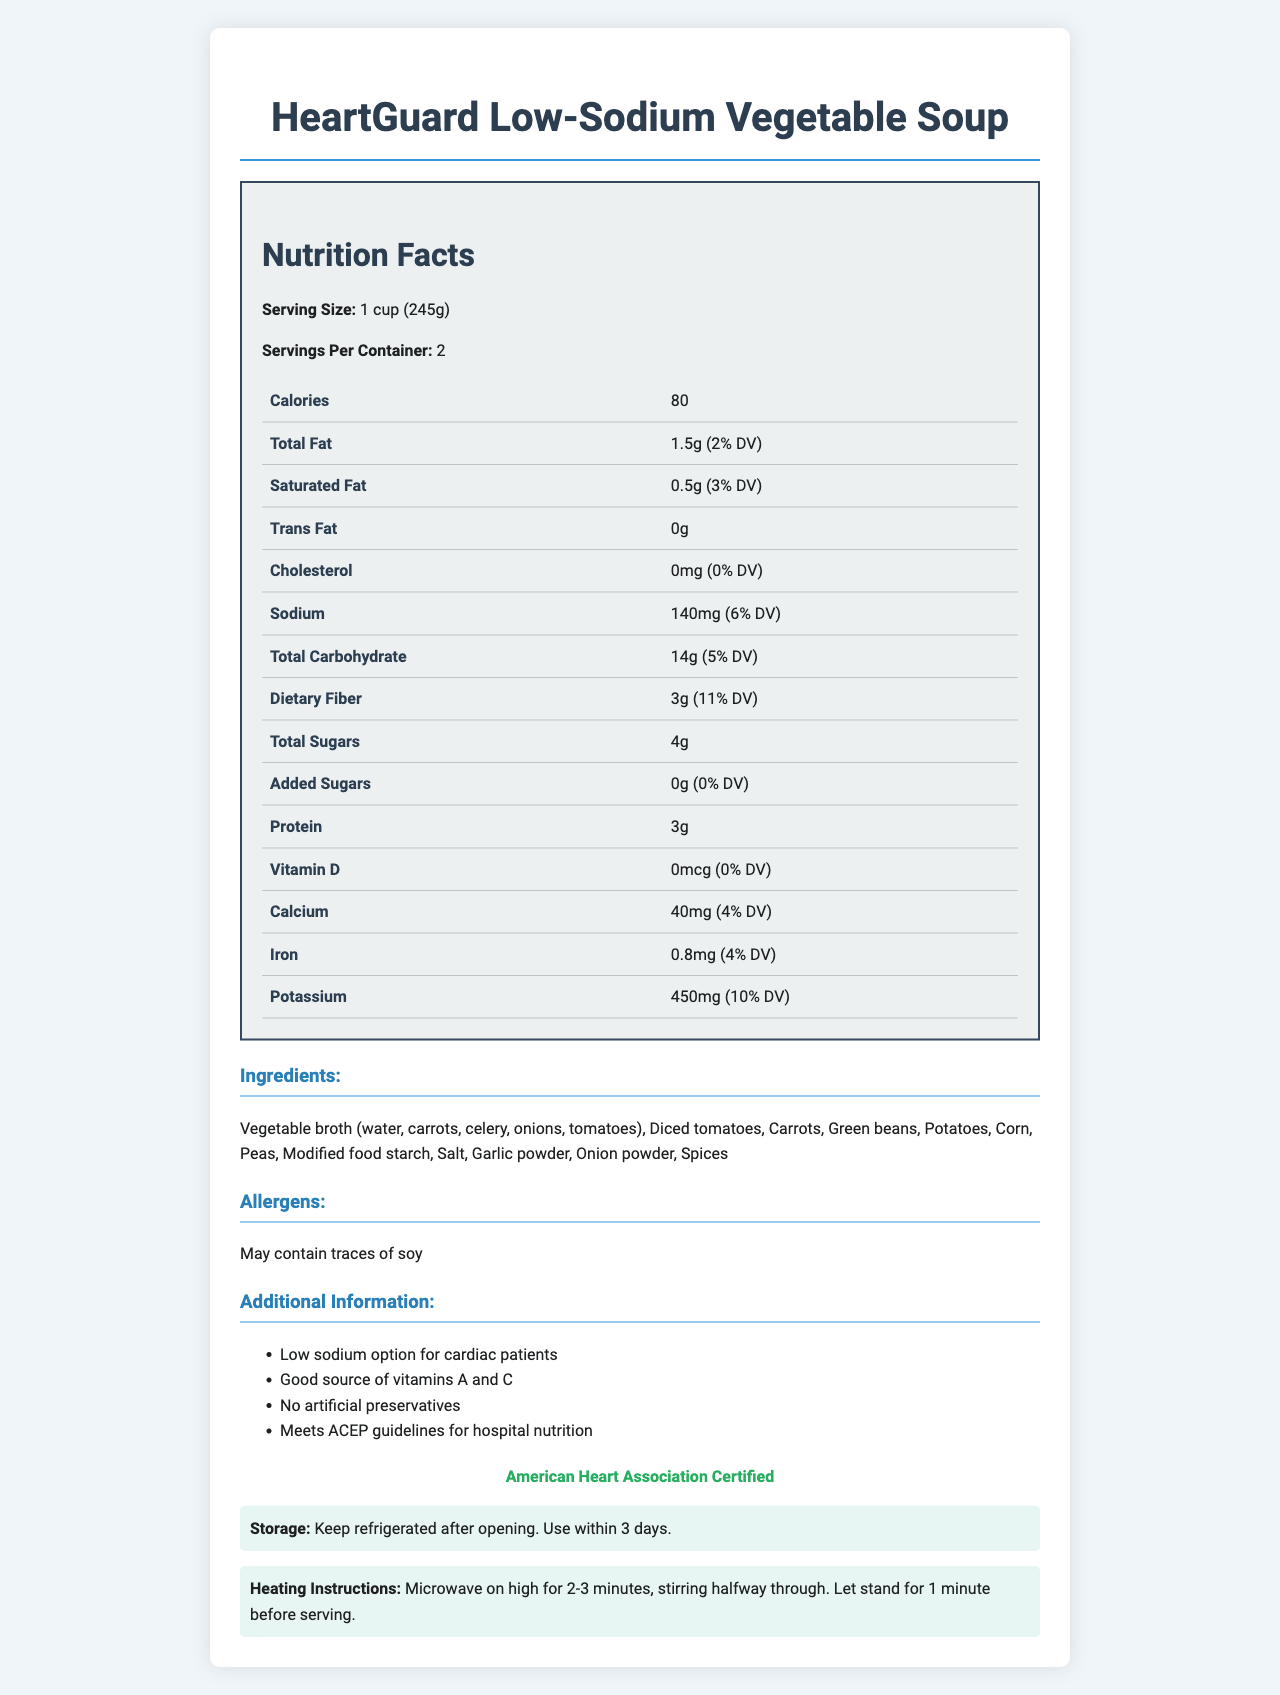How many servings are in a container of HeartGuard Low-Sodium Vegetable Soup? The document states that the "Servings Per Container" is 2.
Answer: 2 What is the serving size of the soup? The document specifies that the serving size is "1 cup (245g)."
Answer: 1 cup (245g) How many calories are in one serving of the soup? The document indicates that each serving contains 80 calories.
Answer: 80 What percentage of the daily value of sodium does one serving contain? The document shows that one serving contains 140mg of sodium, which is 6% of the daily value.
Answer: 6% List all the ingredients in the soup. The document provides a list of ingredients under the "Ingredients" section.
Answer: Vegetable broth (water, carrots, celery, onions, tomatoes), Diced tomatoes, Carrots, Green beans, Potatoes, Corn, Peas, Modified food starch, Salt, Garlic powder, Onion powder, Spices Does the soup contain any cholesterol? The document indicates that the cholesterol amount is 0mg with a daily value of 0%.
Answer: No What allergens might be present in the soup? The allergens section specifies that the soup may contain traces of soy.
Answer: May contain traces of soy What is the amount of dietary fiber in one serving? The document states that each serving contains 3g of dietary fiber.
Answer: 3g When should the soup be consumed after opening if kept refrigerated? The storage instructions state to keep the soup refrigerated after opening and use it within 3 days.
Answer: Within 3 days Which organization has certified the soup? The document mentions that the soup is "American Heart Association Certified."
Answer: American Heart Association How should the soup be heated in a microwave? The heating instructions are clearly stated in the document.
Answer: Microwave on high for 2-3 minutes, stirring halfway through. Let stand for 1 minute before serving. What additional information is provided about the soup? 
A. It contains artificial preservatives 
B. It is a low sodium option for cardiac patients 
C. It does not meet ACEP guidelines 
D. It is not a good source of vitamins The document states "Low sodium option for cardiac patients" under additional information.
Answer: B What is the daily value percentage of calcium in one serving? 
I. 4% 
II. 8% 
III. 10% 
IV. 12% The document indicates that one serving contains 40mg of calcium, which is 4% of the daily value.
Answer: I Does the soup meet the ACEP guidelines for hospital nutrition? The additional information specifies that the soup "Meets ACEP guidelines for hospital nutrition."
Answer: Yes Summarize the main idea of the document. The document includes various sections such as nutrition facts, ingredients, allergens, additional information, certification, storage, and heating instructions to provide comprehensive information about the soup.
Answer: The document provides detailed nutritional information, ingredients, allergens, and instructions for the HeartGuard Low-Sodium Vegetable Soup, highlighting it as a low-sodium and heart-friendly option certified by the American Heart Association and suitable for cardiac patients. It includes specific storage and heating instructions. Which specific vitamins are considered good sources in the soup? The document mentions the soup is a "Good source of vitamins A and C" but does not provide specific quantities.
Answer: Not enough information 